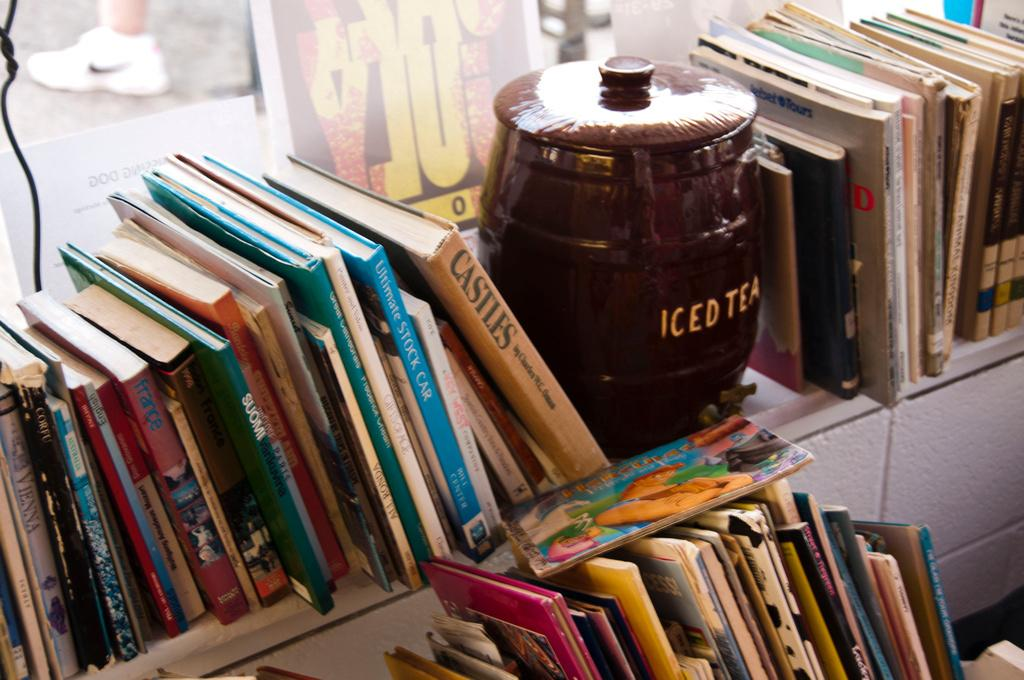Provide a one-sentence caption for the provided image. A shelf of books with an iced tea barrel. 